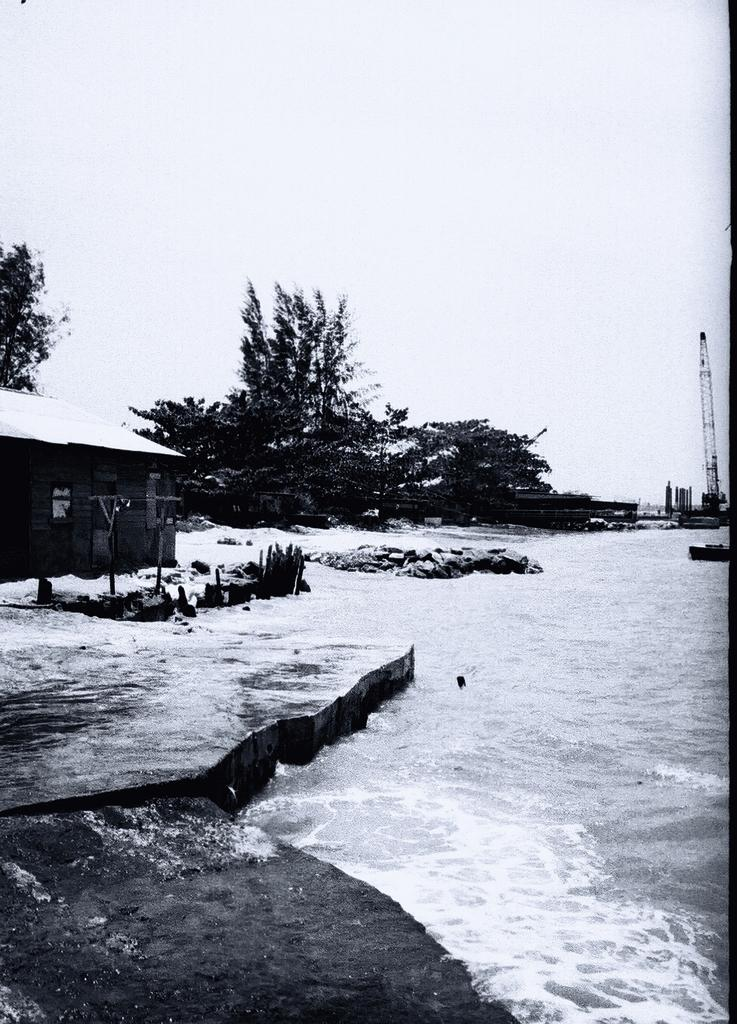What type of natural elements can be seen in the image? There are rocks and water visible in the image. What type of structures are present in the image? There is a house and a tower in the image. What type of vegetation is present in the image? There are trees in the image. What else can be seen in the image besides the mentioned elements? There are some unspecified objects in the image. What is visible in the background of the image? The sky is visible in the background of the image. What type of pin can be seen holding the fear in the image? There is no pin or fear present in the image. Is there a bath visible in the image? There is no bath present in the image. 